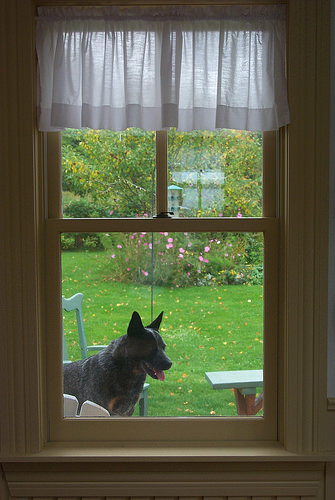<image>
Is the dog behind the grass? No. The dog is not behind the grass. From this viewpoint, the dog appears to be positioned elsewhere in the scene. 